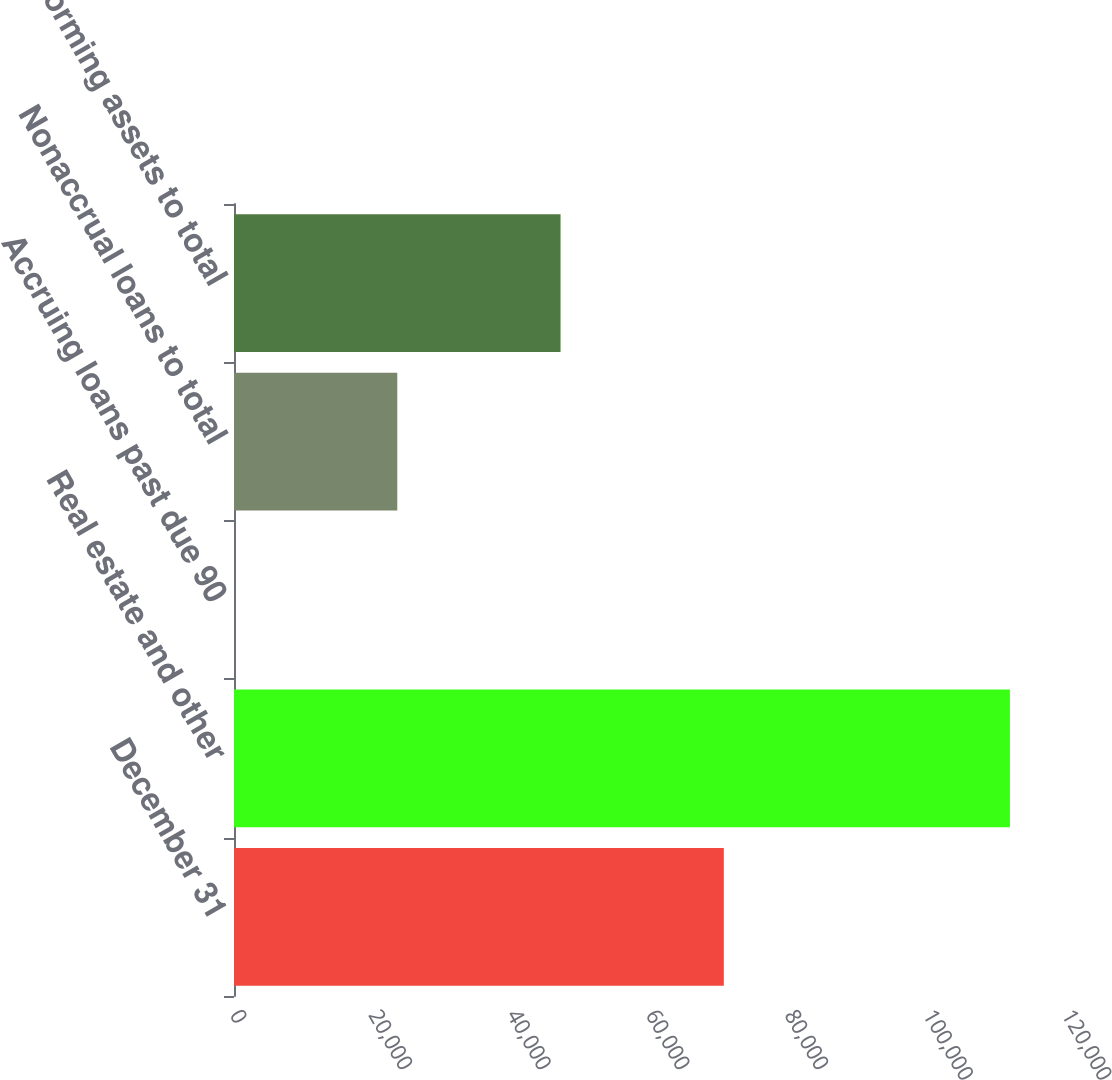<chart> <loc_0><loc_0><loc_500><loc_500><bar_chart><fcel>December 31<fcel>Real estate and other<fcel>Accruing loans past due 90<fcel>Nonaccrual loans to total<fcel>Nonperforming assets to total<nl><fcel>70646.9<fcel>111910<fcel>0.28<fcel>23549.2<fcel>47098<nl></chart> 